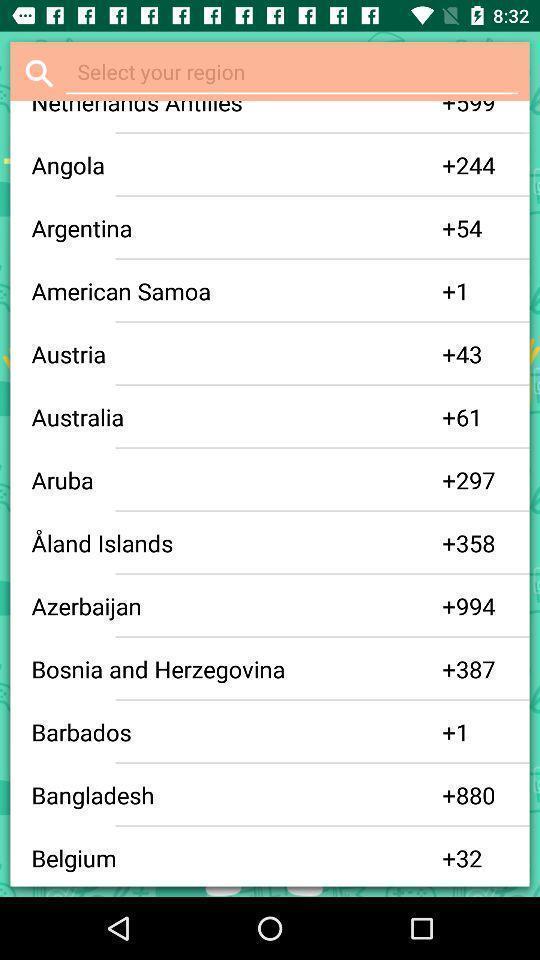Describe this image in words. Screen displaying the list of regions. 